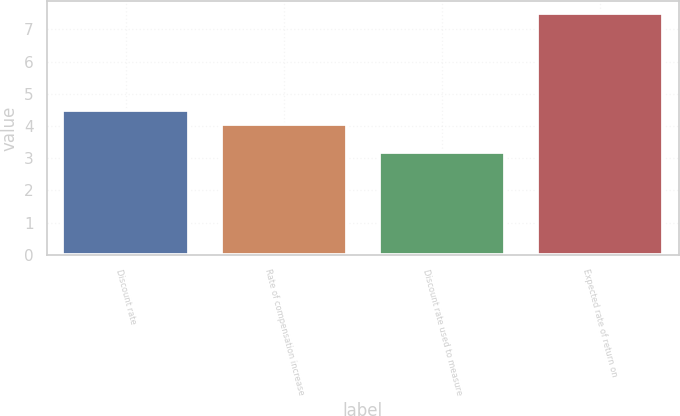<chart> <loc_0><loc_0><loc_500><loc_500><bar_chart><fcel>Discount rate<fcel>Rate of compensation increase<fcel>Discount rate used to measure<fcel>Expected rate of return on<nl><fcel>4.49<fcel>4.06<fcel>3.2<fcel>7.5<nl></chart> 